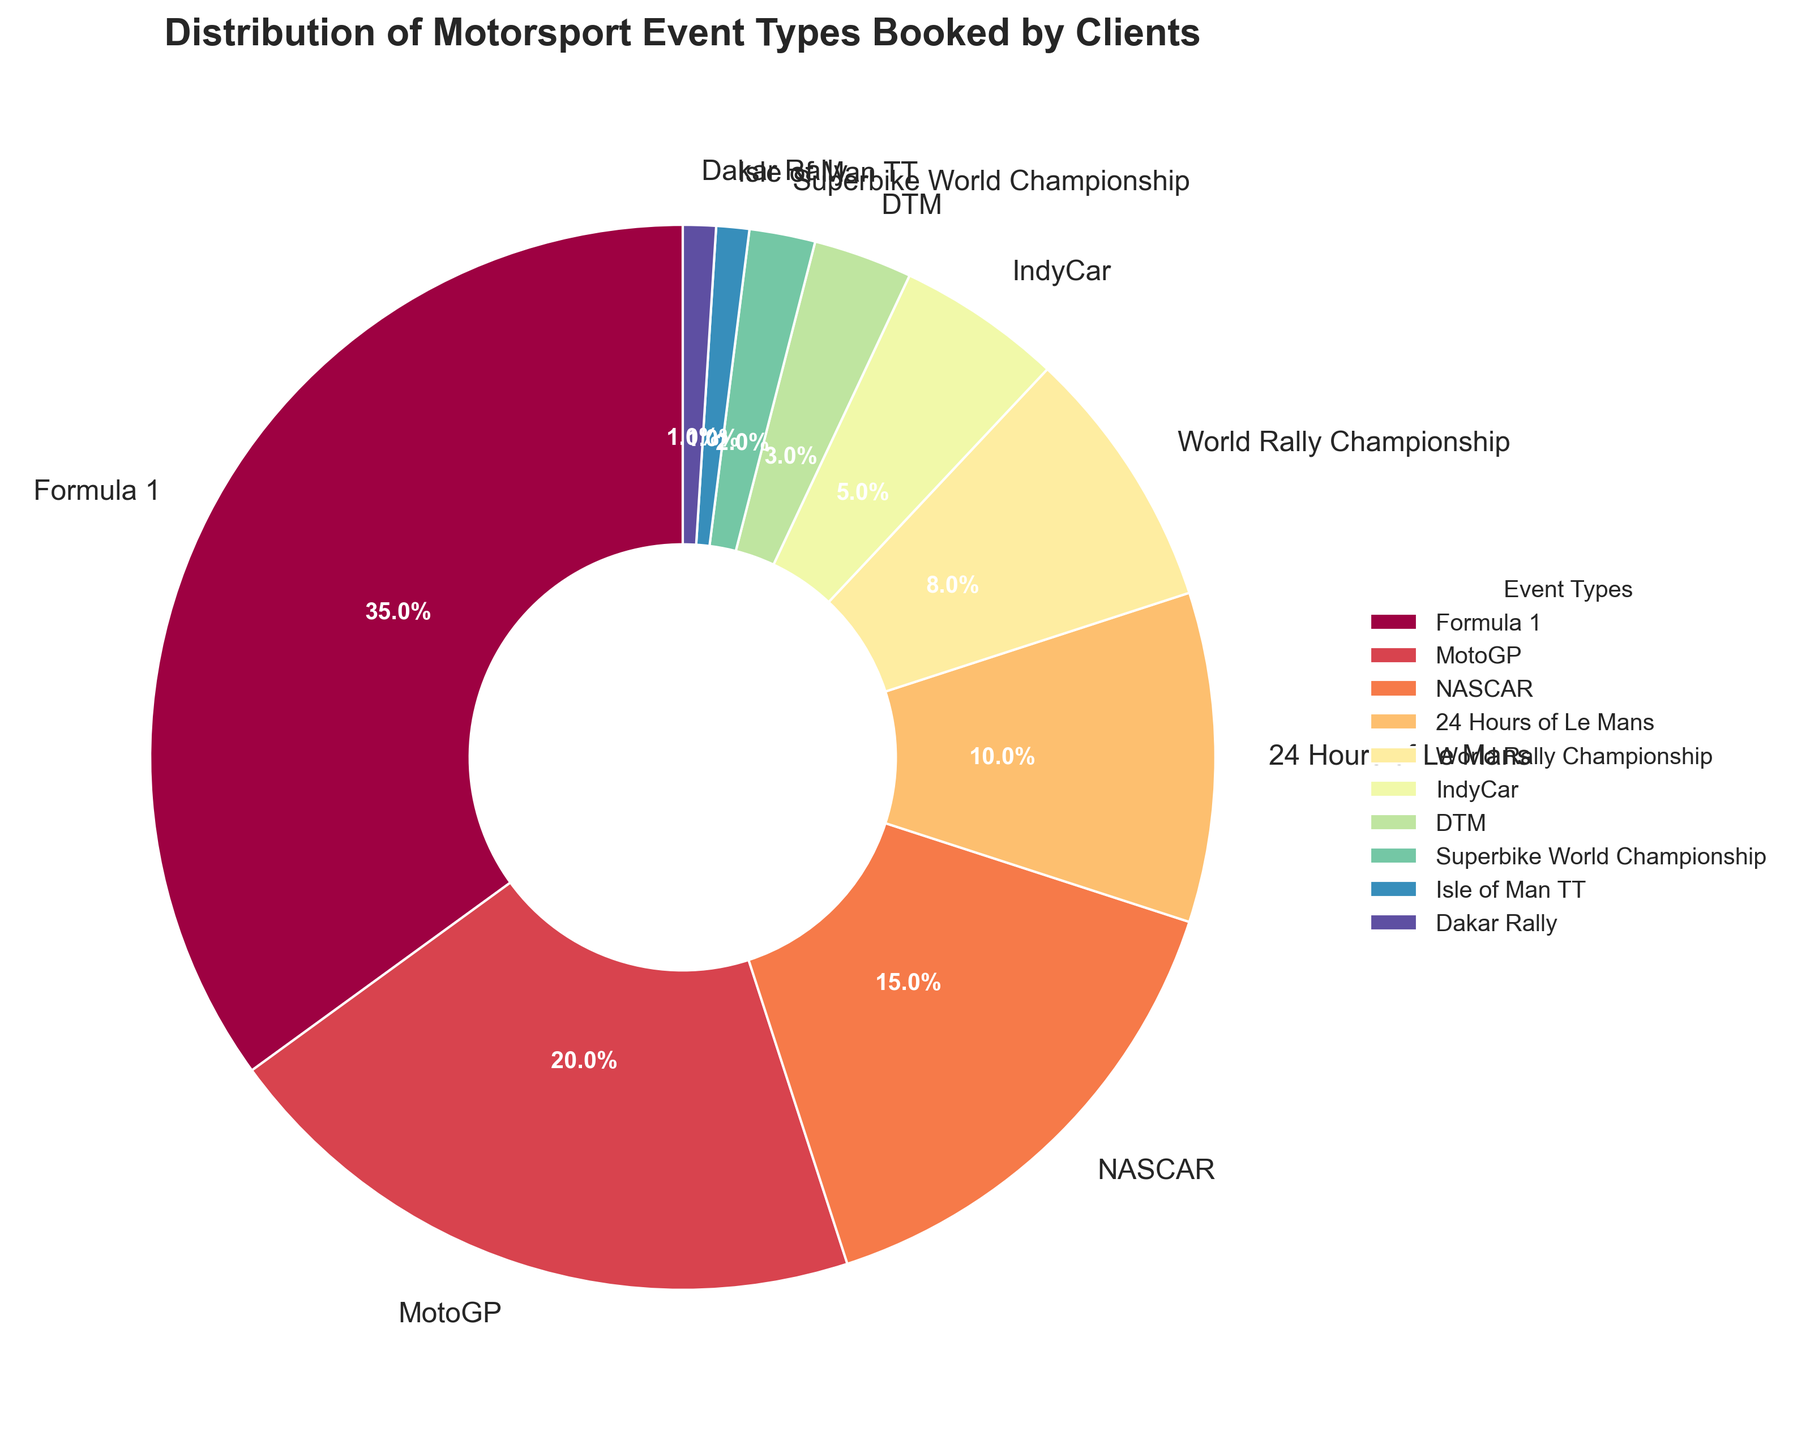What is the most popular motorsport event booked by clients? The largest slice in the pie chart represents the most popular motorsport event. The Formula 1 section occupies 35% of the chart, making it the largest segment.
Answer: Formula 1 Which motorsport event has a higher booking percentage, MotoGP or NASCAR? By comparing the size of the slices labeled MotoGP and NASCAR, MotoGP has 20%, while NASCAR has 15%. Therefore, MotoGP has a higher booking percentage.
Answer: MotoGP What is the combined booking percentage for the events with the lowest two percentages? The lowest two percentages are Isle of Man TT and Dakar Rally, both at 1%. Their combined booking percentage is 1% + 1% which equals 2%.
Answer: 2% Is the percentage of bookings for World Rally Championship greater than IndyCar? The World Rally Championship sector is marked as 8%, which is greater than the 5% allocated to IndyCar.
Answer: Yes Which events constitute more than 10% of the bookings each? Events whose slices are greater than the 10% threshold are Formula 1 (35%) and MotoGP (20%).
Answer: Formula 1 and MotoGP How much smaller is the DTM booking percentage compared to the World Rally Championship? DTM has 3% of the bookings, whereas World Rally Championship has 8%. The difference is calculated as 8% - 3%, resulting in 5%.
Answer: 5% What is the total percentage of bookings for Formula 1 and MotoGP combined? Adding the percentages for Formula 1 (35%) and MotoGP (20%) gives a combined total of 55%.
Answer: 55% Which event has the third-highest booking percentage, and what is it? The top three events in descending order are Formula 1 (35%), MotoGP (20%), and NASCAR (15%). Therefore, NASCAR is the event with the third-highest booking percentage.
Answer: NASCAR, 15% If you exclude Formula 1 bookings, what is the average booking percentage for the remaining events? First, remove Formula 1 (35%) and sum up the remaining percentages: 20 + 15 + 10 + 8 + 5 + 3 + 2 + 1 + 1 = 65. There are 9 events left. So, the average is 65% / 9 ≈ 7.22%.
Answer: 7.22% Does the cumulative percentage of NASCAR and 24 Hours of Le Mans exceed that of Formula 1? NASCAR has 15% and 24 Hours of Le Mans has 10%, making their cumulative percentage 15% + 10% = 25%. This is less than the 35% of Formula 1.
Answer: No 